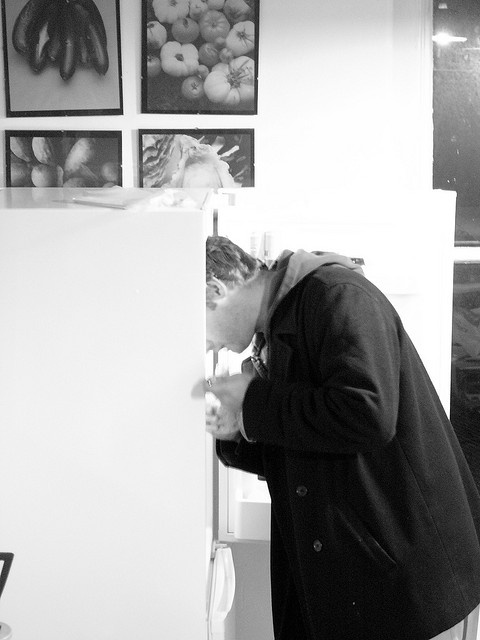Describe the objects in this image and their specific colors. I can see refrigerator in gray, white, darkgray, and black tones and people in gray, black, darkgray, and lightgray tones in this image. 